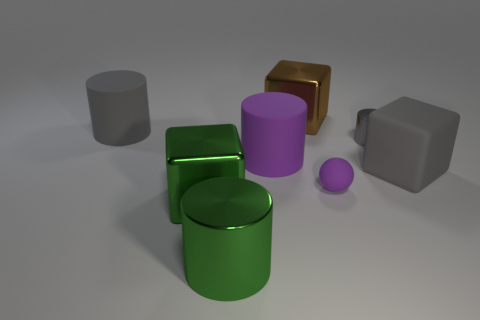Subtract all metallic cubes. How many cubes are left? 1 Subtract all green cylinders. How many cylinders are left? 3 Subtract 1 blocks. How many blocks are left? 2 Add 2 big yellow shiny blocks. How many objects exist? 10 Subtract all blocks. How many objects are left? 5 Subtract all large brown metallic blocks. Subtract all tiny green metal spheres. How many objects are left? 7 Add 6 brown metal things. How many brown metal things are left? 7 Add 4 big purple matte cylinders. How many big purple matte cylinders exist? 5 Subtract 1 brown blocks. How many objects are left? 7 Subtract all cyan cylinders. Subtract all purple spheres. How many cylinders are left? 4 